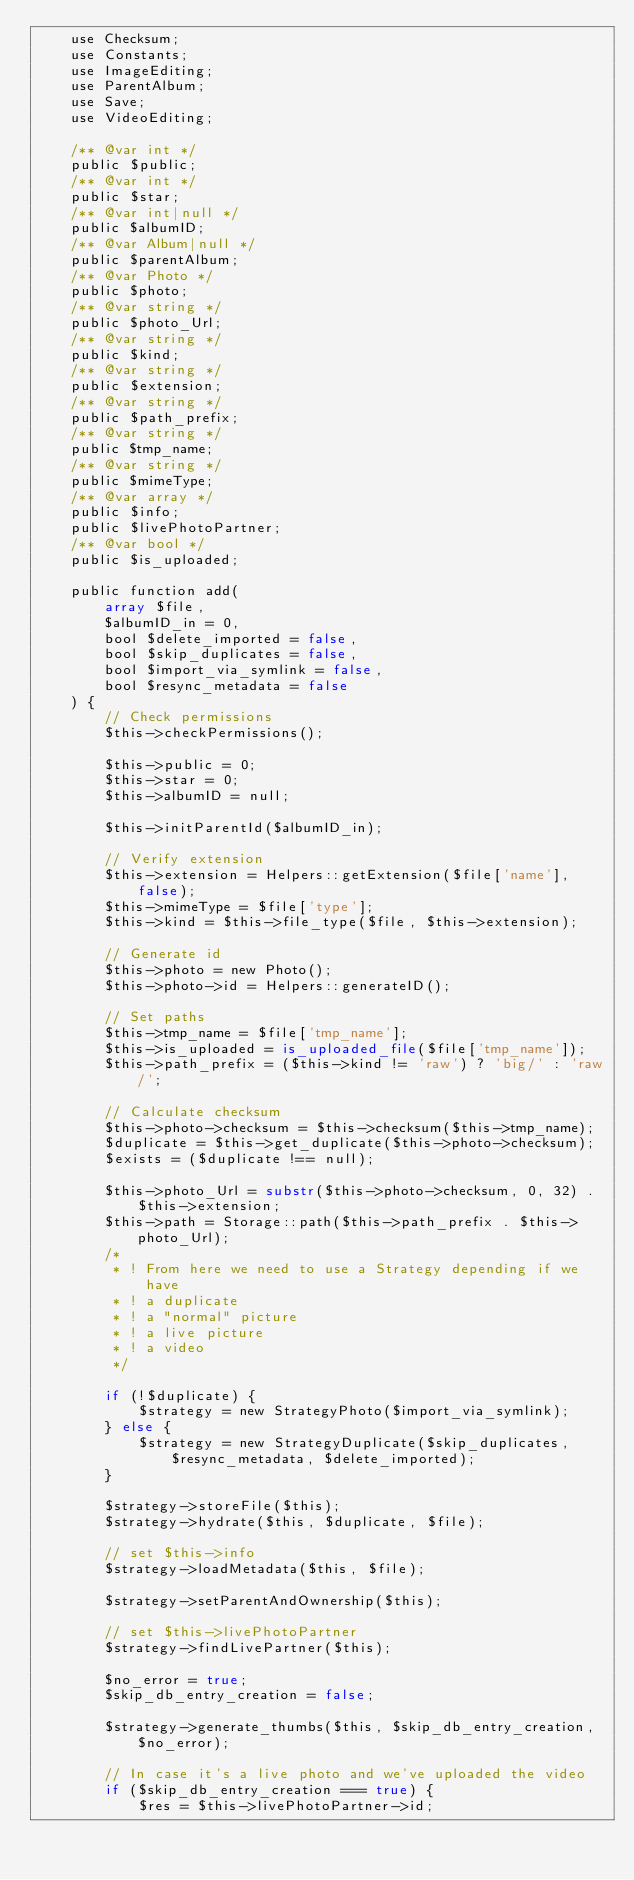Convert code to text. <code><loc_0><loc_0><loc_500><loc_500><_PHP_>	use Checksum;
	use Constants;
	use ImageEditing;
	use ParentAlbum;
	use Save;
	use VideoEditing;

	/** @var int */
	public $public;
	/** @var int */
	public $star;
	/** @var int|null */
	public $albumID;
	/** @var Album|null */
	public $parentAlbum;
	/** @var Photo */
	public $photo;
	/** @var string */
	public $photo_Url;
	/** @var string */
	public $kind;
	/** @var string */
	public $extension;
	/** @var string */
	public $path_prefix;
	/** @var string */
	public $tmp_name;
	/** @var string */
	public $mimeType;
	/** @var array */
	public $info;
	public $livePhotoPartner;
	/** @var bool */
	public $is_uploaded;

	public function add(
		array $file,
		$albumID_in = 0,
		bool $delete_imported = false,
		bool $skip_duplicates = false,
		bool $import_via_symlink = false,
		bool $resync_metadata = false
	) {
		// Check permissions
		$this->checkPermissions();

		$this->public = 0;
		$this->star = 0;
		$this->albumID = null;

		$this->initParentId($albumID_in);

		// Verify extension
		$this->extension = Helpers::getExtension($file['name'], false);
		$this->mimeType = $file['type'];
		$this->kind = $this->file_type($file, $this->extension);

		// Generate id
		$this->photo = new Photo();
		$this->photo->id = Helpers::generateID();

		// Set paths
		$this->tmp_name = $file['tmp_name'];
		$this->is_uploaded = is_uploaded_file($file['tmp_name']);
		$this->path_prefix = ($this->kind != 'raw') ? 'big/' : 'raw/';

		// Calculate checksum
		$this->photo->checksum = $this->checksum($this->tmp_name);
		$duplicate = $this->get_duplicate($this->photo->checksum);
		$exists = ($duplicate !== null);

		$this->photo_Url = substr($this->photo->checksum, 0, 32) . $this->extension;
		$this->path = Storage::path($this->path_prefix . $this->photo_Url);
		/*
		 * ! From here we need to use a Strategy depending if we have
		 * ! a duplicate
		 * ! a "normal" picture
		 * ! a live picture
		 * ! a video
		 */

		if (!$duplicate) {
			$strategy = new StrategyPhoto($import_via_symlink);
		} else {
			$strategy = new StrategyDuplicate($skip_duplicates, $resync_metadata, $delete_imported);
		}

		$strategy->storeFile($this);
		$strategy->hydrate($this, $duplicate, $file);

		// set $this->info
		$strategy->loadMetadata($this, $file);

		$strategy->setParentAndOwnership($this);

		// set $this->livePhotoPartner
		$strategy->findLivePartner($this);

		$no_error = true;
		$skip_db_entry_creation = false;

		$strategy->generate_thumbs($this, $skip_db_entry_creation, $no_error);

		// In case it's a live photo and we've uploaded the video
		if ($skip_db_entry_creation === true) {
			$res = $this->livePhotoPartner->id;</code> 